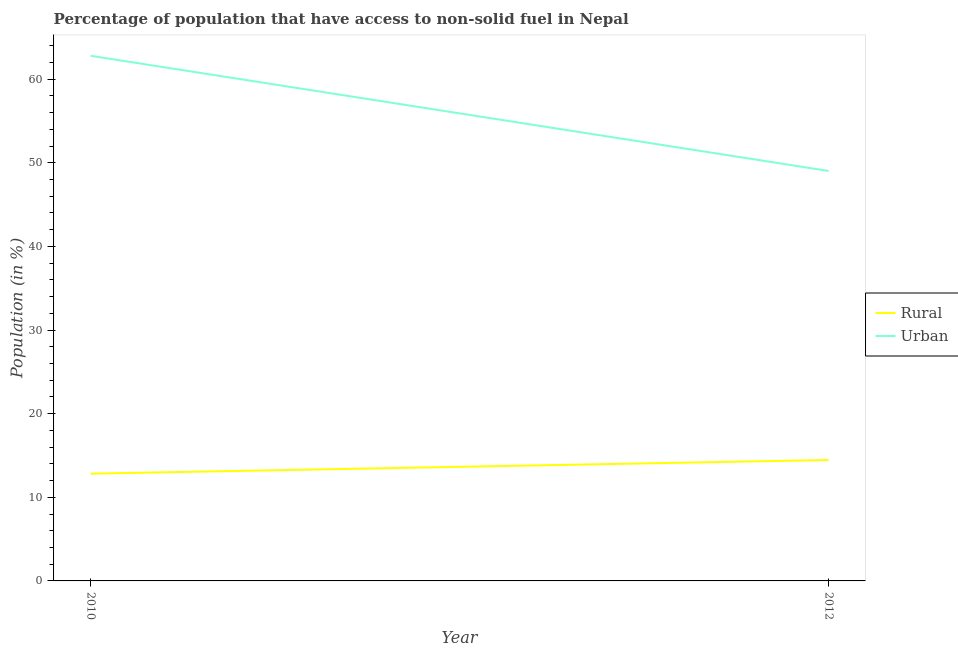How many different coloured lines are there?
Offer a very short reply. 2. Does the line corresponding to urban population intersect with the line corresponding to rural population?
Offer a terse response. No. Is the number of lines equal to the number of legend labels?
Your response must be concise. Yes. What is the urban population in 2012?
Offer a terse response. 49.02. Across all years, what is the maximum urban population?
Provide a short and direct response. 62.79. Across all years, what is the minimum urban population?
Provide a short and direct response. 49.02. What is the total urban population in the graph?
Your answer should be compact. 111.82. What is the difference between the urban population in 2010 and that in 2012?
Provide a short and direct response. 13.77. What is the difference between the rural population in 2012 and the urban population in 2010?
Your response must be concise. -48.33. What is the average rural population per year?
Give a very brief answer. 13.64. In the year 2012, what is the difference between the urban population and rural population?
Give a very brief answer. 34.56. In how many years, is the rural population greater than 8 %?
Keep it short and to the point. 2. What is the ratio of the urban population in 2010 to that in 2012?
Keep it short and to the point. 1.28. In how many years, is the rural population greater than the average rural population taken over all years?
Make the answer very short. 1. Is the urban population strictly greater than the rural population over the years?
Make the answer very short. Yes. How many lines are there?
Offer a terse response. 2. How many years are there in the graph?
Your answer should be very brief. 2. How many legend labels are there?
Your answer should be compact. 2. How are the legend labels stacked?
Provide a short and direct response. Vertical. What is the title of the graph?
Your answer should be compact. Percentage of population that have access to non-solid fuel in Nepal. What is the label or title of the X-axis?
Your answer should be very brief. Year. What is the label or title of the Y-axis?
Your answer should be compact. Population (in %). What is the Population (in %) in Rural in 2010?
Ensure brevity in your answer.  12.83. What is the Population (in %) in Urban in 2010?
Offer a terse response. 62.79. What is the Population (in %) of Rural in 2012?
Offer a terse response. 14.46. What is the Population (in %) of Urban in 2012?
Offer a very short reply. 49.02. Across all years, what is the maximum Population (in %) of Rural?
Give a very brief answer. 14.46. Across all years, what is the maximum Population (in %) of Urban?
Make the answer very short. 62.79. Across all years, what is the minimum Population (in %) in Rural?
Your answer should be very brief. 12.83. Across all years, what is the minimum Population (in %) in Urban?
Your answer should be compact. 49.02. What is the total Population (in %) of Rural in the graph?
Make the answer very short. 27.29. What is the total Population (in %) in Urban in the graph?
Provide a short and direct response. 111.82. What is the difference between the Population (in %) in Rural in 2010 and that in 2012?
Provide a short and direct response. -1.63. What is the difference between the Population (in %) of Urban in 2010 and that in 2012?
Ensure brevity in your answer.  13.77. What is the difference between the Population (in %) in Rural in 2010 and the Population (in %) in Urban in 2012?
Make the answer very short. -36.2. What is the average Population (in %) in Rural per year?
Your answer should be compact. 13.64. What is the average Population (in %) in Urban per year?
Give a very brief answer. 55.91. In the year 2010, what is the difference between the Population (in %) in Rural and Population (in %) in Urban?
Make the answer very short. -49.97. In the year 2012, what is the difference between the Population (in %) of Rural and Population (in %) of Urban?
Provide a short and direct response. -34.56. What is the ratio of the Population (in %) in Rural in 2010 to that in 2012?
Make the answer very short. 0.89. What is the ratio of the Population (in %) of Urban in 2010 to that in 2012?
Ensure brevity in your answer.  1.28. What is the difference between the highest and the second highest Population (in %) of Rural?
Provide a short and direct response. 1.63. What is the difference between the highest and the second highest Population (in %) in Urban?
Provide a succinct answer. 13.77. What is the difference between the highest and the lowest Population (in %) in Rural?
Your answer should be compact. 1.63. What is the difference between the highest and the lowest Population (in %) in Urban?
Keep it short and to the point. 13.77. 